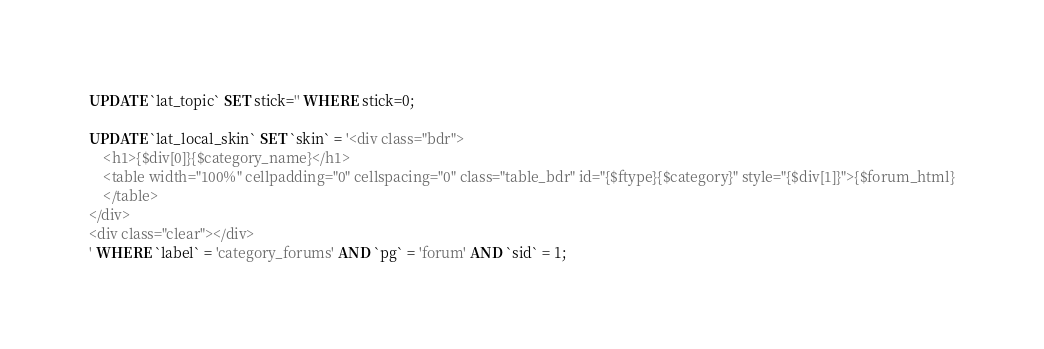<code> <loc_0><loc_0><loc_500><loc_500><_SQL_>UPDATE `lat_topic` SET stick='' WHERE stick=0;

UPDATE `lat_local_skin` SET `skin` = '<div class="bdr">
	<h1>{$div[0]}{$category_name}</h1>
	<table width="100%" cellpadding="0" cellspacing="0" class="table_bdr" id="{$ftype}{$category}" style="{$div[1]}">{$forum_html}
	</table>
</div>
<div class="clear"></div>
' WHERE `label` = 'category_forums' AND `pg` = 'forum' AND `sid` = 1;
</code> 